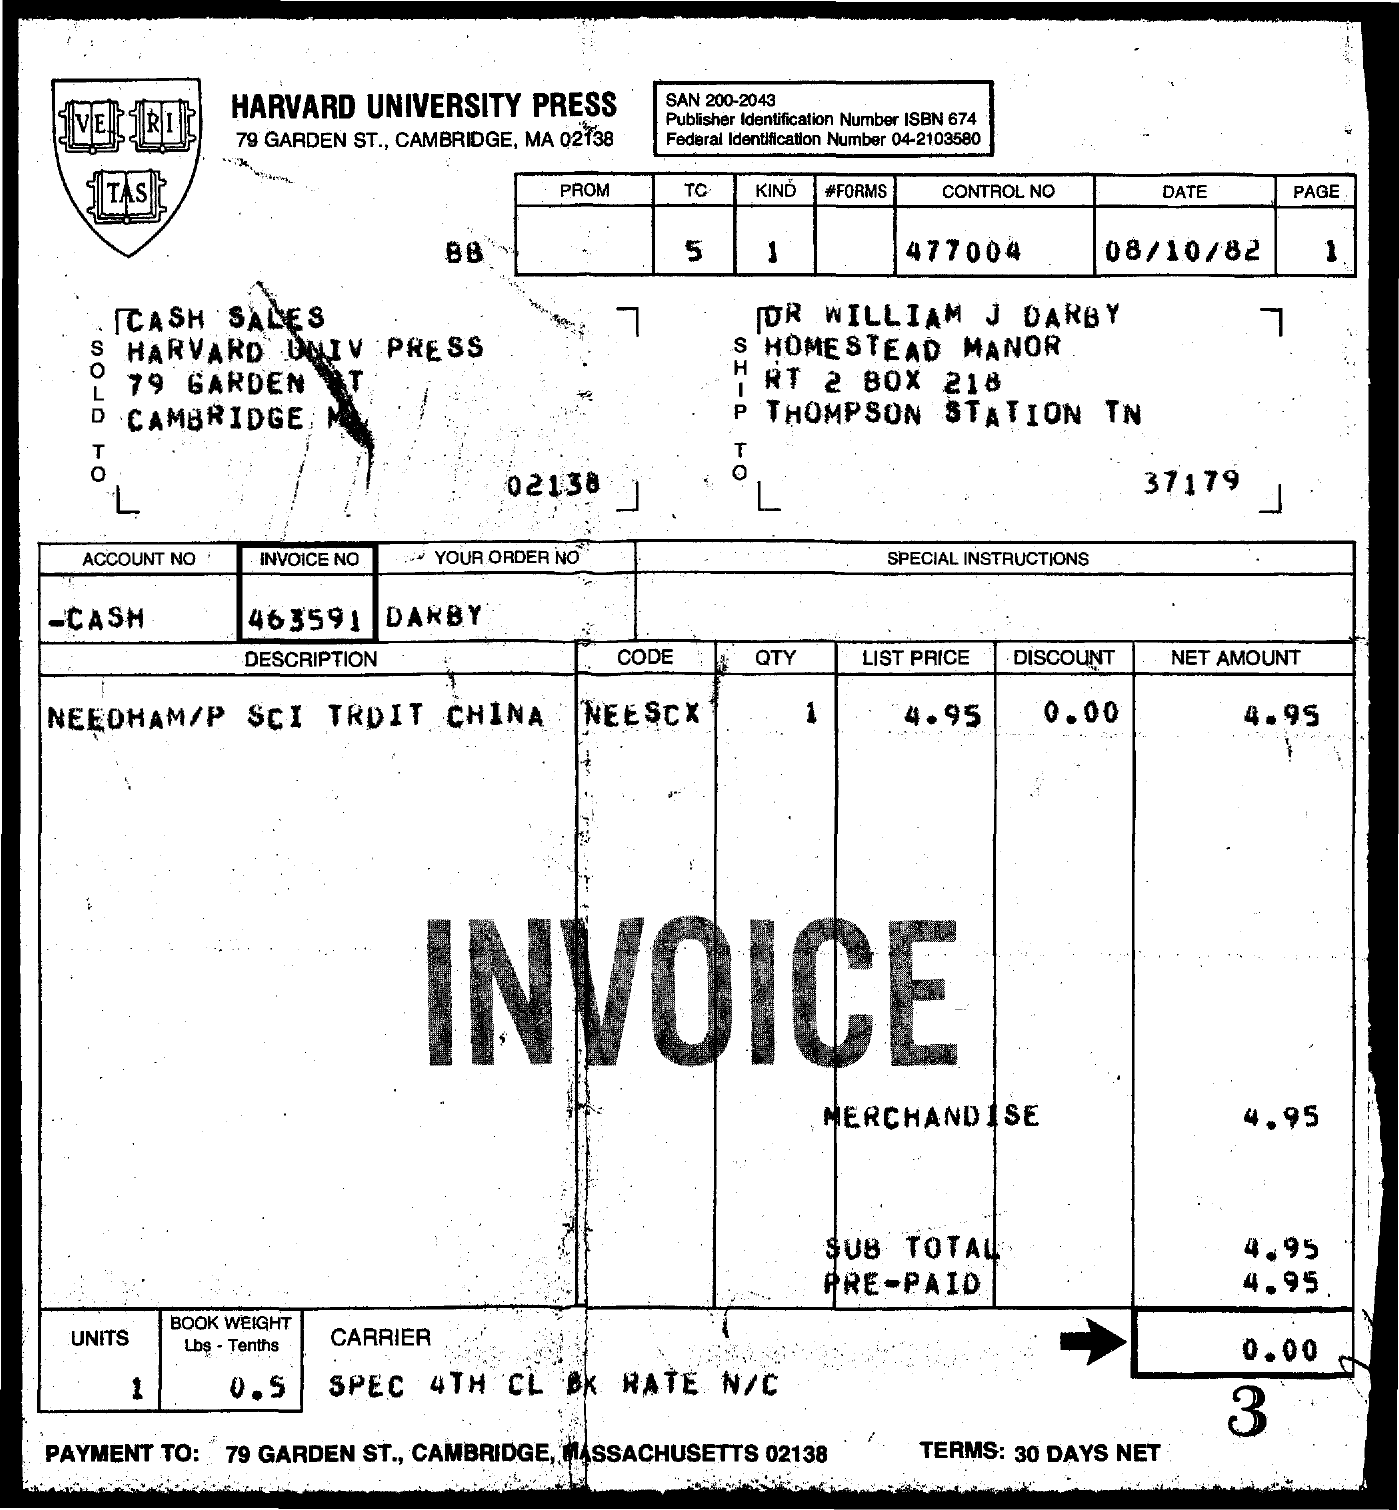List a handful of essential elements in this visual. The control number provided on the invoice is 477004... The page number mentioned in the invoice is 1. The net amount for the merchandise as indicated in the invoice is 4.95. The book weight mentioned in the invoice form is 0.5 tenths. The date mentioned in the invoice is 08/10/82. 